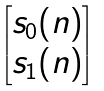Convert formula to latex. <formula><loc_0><loc_0><loc_500><loc_500>\begin{bmatrix} s _ { 0 } ( n ) \\ s _ { 1 } ( n ) \end{bmatrix}</formula> 